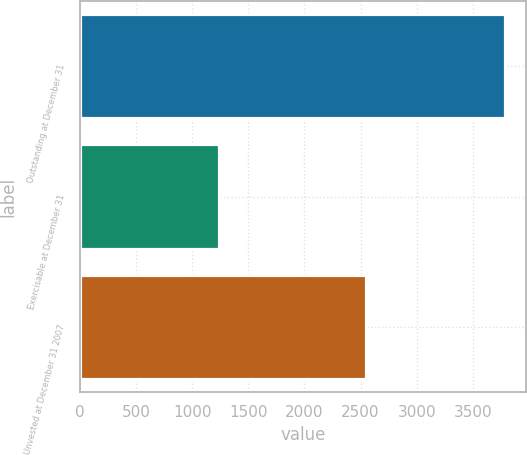Convert chart to OTSL. <chart><loc_0><loc_0><loc_500><loc_500><bar_chart><fcel>Outstanding at December 31<fcel>Exercisable at December 31<fcel>Unvested at December 31 2007<nl><fcel>3787<fcel>1241<fcel>2546<nl></chart> 